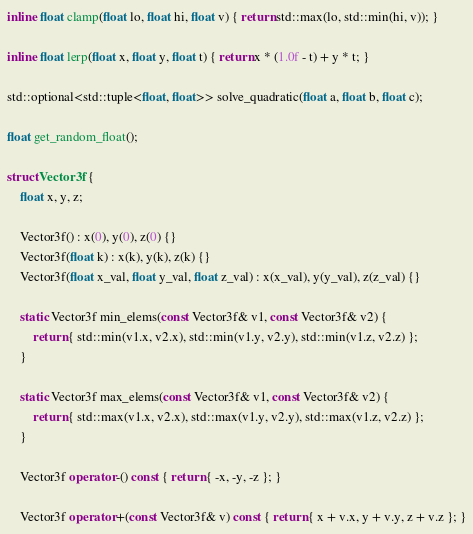Convert code to text. <code><loc_0><loc_0><loc_500><loc_500><_C++_>inline float clamp(float lo, float hi, float v) { return std::max(lo, std::min(hi, v)); }

inline float lerp(float x, float y, float t) { return x * (1.0f - t) + y * t; }

std::optional<std::tuple<float, float>> solve_quadratic(float a, float b, float c);

float get_random_float();

struct Vector3f {
    float x, y, z;

    Vector3f() : x(0), y(0), z(0) {}
    Vector3f(float k) : x(k), y(k), z(k) {}
    Vector3f(float x_val, float y_val, float z_val) : x(x_val), y(y_val), z(z_val) {}

    static Vector3f min_elems(const Vector3f& v1, const Vector3f& v2) {
        return { std::min(v1.x, v2.x), std::min(v1.y, v2.y), std::min(v1.z, v2.z) };
    }

    static Vector3f max_elems(const Vector3f& v1, const Vector3f& v2) {
        return { std::max(v1.x, v2.x), std::max(v1.y, v2.y), std::max(v1.z, v2.z) };
    }

    Vector3f operator -() const { return { -x, -y, -z }; }

    Vector3f operator +(const Vector3f& v) const { return { x + v.x, y + v.y, z + v.z }; }
</code> 